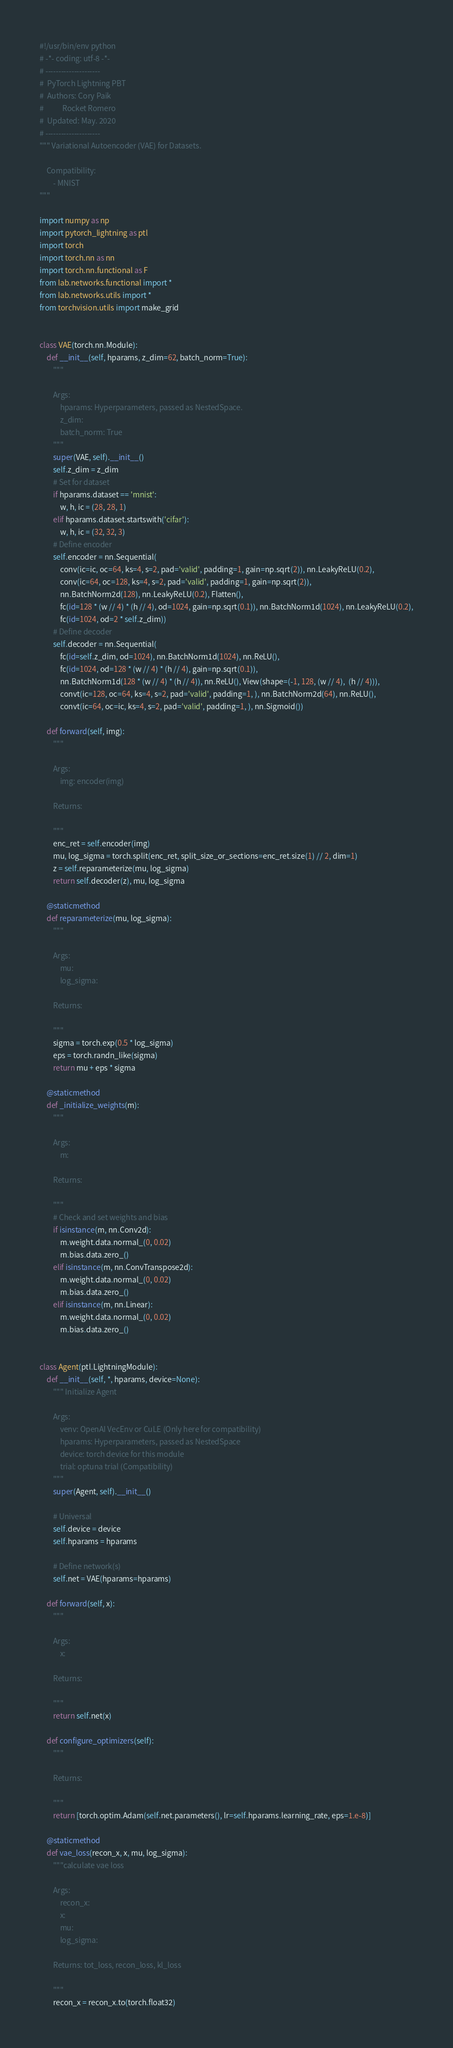<code> <loc_0><loc_0><loc_500><loc_500><_Python_>#!/usr/bin/env python
# -*- coding: utf-8 -*-
# ---------------------
#  PyTorch Lightning PBT
#  Authors: Cory Paik
#           Rocket Romero
#  Updated: May. 2020
# ---------------------
""" Variational Autoencoder (VAE) for Datasets.

    Compatibility:
        - MNIST
"""

import numpy as np
import pytorch_lightning as ptl
import torch
import torch.nn as nn
import torch.nn.functional as F
from lab.networks.functional import *
from lab.networks.utils import *
from torchvision.utils import make_grid


class VAE(torch.nn.Module):
    def __init__(self, hparams, z_dim=62, batch_norm=True):
        """

        Args:
            hparams: Hyperparameters, passed as NestedSpace.
            z_dim:
            batch_norm: True
        """
        super(VAE, self).__init__()
        self.z_dim = z_dim
        # Set for dataset
        if hparams.dataset == 'mnist':
            w, h, ic = (28, 28, 1)
        elif hparams.dataset.startswith('cifar'):
            w, h, ic = (32, 32, 3)
        # Define encoder
        self.encoder = nn.Sequential(
            conv(ic=ic, oc=64, ks=4, s=2, pad='valid', padding=1, gain=np.sqrt(2)), nn.LeakyReLU(0.2),
            conv(ic=64, oc=128, ks=4, s=2, pad='valid', padding=1, gain=np.sqrt(2)),
            nn.BatchNorm2d(128), nn.LeakyReLU(0.2), Flatten(),
            fc(id=128 * (w // 4) * (h // 4), od=1024, gain=np.sqrt(0.1)), nn.BatchNorm1d(1024), nn.LeakyReLU(0.2),
            fc(id=1024, od=2 * self.z_dim))
        # Define decoder
        self.decoder = nn.Sequential(
            fc(id=self.z_dim, od=1024), nn.BatchNorm1d(1024), nn.ReLU(),
            fc(id=1024, od=128 * (w // 4) * (h // 4), gain=np.sqrt(0.1)),
            nn.BatchNorm1d(128 * (w // 4) * (h // 4)), nn.ReLU(), View(shape=(-1, 128, (w // 4),  (h // 4))),
            convt(ic=128, oc=64, ks=4, s=2, pad='valid', padding=1, ), nn.BatchNorm2d(64), nn.ReLU(),
            convt(ic=64, oc=ic, ks=4, s=2, pad='valid', padding=1, ), nn.Sigmoid())

    def forward(self, img):
        """

        Args:
            img: encoder(img)

        Returns:

        """
        enc_ret = self.encoder(img)
        mu, log_sigma = torch.split(enc_ret, split_size_or_sections=enc_ret.size(1) // 2, dim=1)
        z = self.reparameterize(mu, log_sigma)
        return self.decoder(z), mu, log_sigma

    @staticmethod
    def reparameterize(mu, log_sigma):
        """

        Args:
            mu:
            log_sigma:

        Returns:

        """
        sigma = torch.exp(0.5 * log_sigma)
        eps = torch.randn_like(sigma)
        return mu + eps * sigma

    @staticmethod
    def _initialize_weights(m):
        """

        Args:
            m:

        Returns:

        """
        # Check and set weights and bias
        if isinstance(m, nn.Conv2d):
            m.weight.data.normal_(0, 0.02)
            m.bias.data.zero_()
        elif isinstance(m, nn.ConvTranspose2d):
            m.weight.data.normal_(0, 0.02)
            m.bias.data.zero_()
        elif isinstance(m, nn.Linear):
            m.weight.data.normal_(0, 0.02)
            m.bias.data.zero_()


class Agent(ptl.LightningModule):
    def __init__(self, *, hparams, device=None):
        """ Initialize Agent

        Args:
            venv: OpenAI VecEnv or CuLE (Only here for compatibility)
            hparams: Hyperparameters, passed as NestedSpace
            device: torch device for this module
            trial: optuna trial (Compatibility)
        """
        super(Agent, self).__init__()

        # Universal
        self.device = device
        self.hparams = hparams

        # Define network(s)
        self.net = VAE(hparams=hparams)

    def forward(self, x):
        """

        Args:
            x:

        Returns:

        """
        return self.net(x)

    def configure_optimizers(self):
        """

        Returns:

        """
        return [torch.optim.Adam(self.net.parameters(), lr=self.hparams.learning_rate, eps=1.e-8)]

    @staticmethod
    def vae_loss(recon_x, x, mu, log_sigma):
        """calculate vae loss

        Args:
            recon_x:
            x:
            mu:
            log_sigma:

        Returns: tot_loss, recon_loss, kl_loss

        """
        recon_x = recon_x.to(torch.float32)</code> 